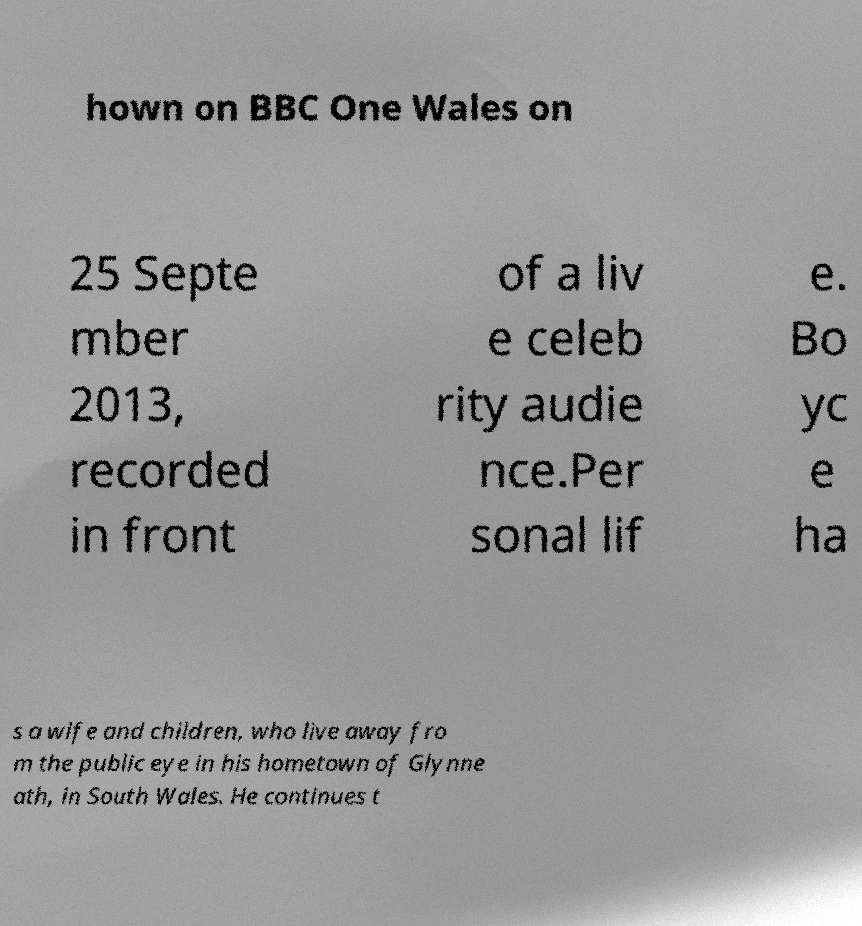Can you accurately transcribe the text from the provided image for me? hown on BBC One Wales on 25 Septe mber 2013, recorded in front of a liv e celeb rity audie nce.Per sonal lif e. Bo yc e ha s a wife and children, who live away fro m the public eye in his hometown of Glynne ath, in South Wales. He continues t 